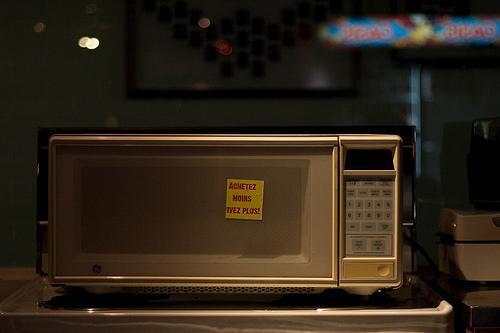How many microwaves are there?
Give a very brief answer. 1. 